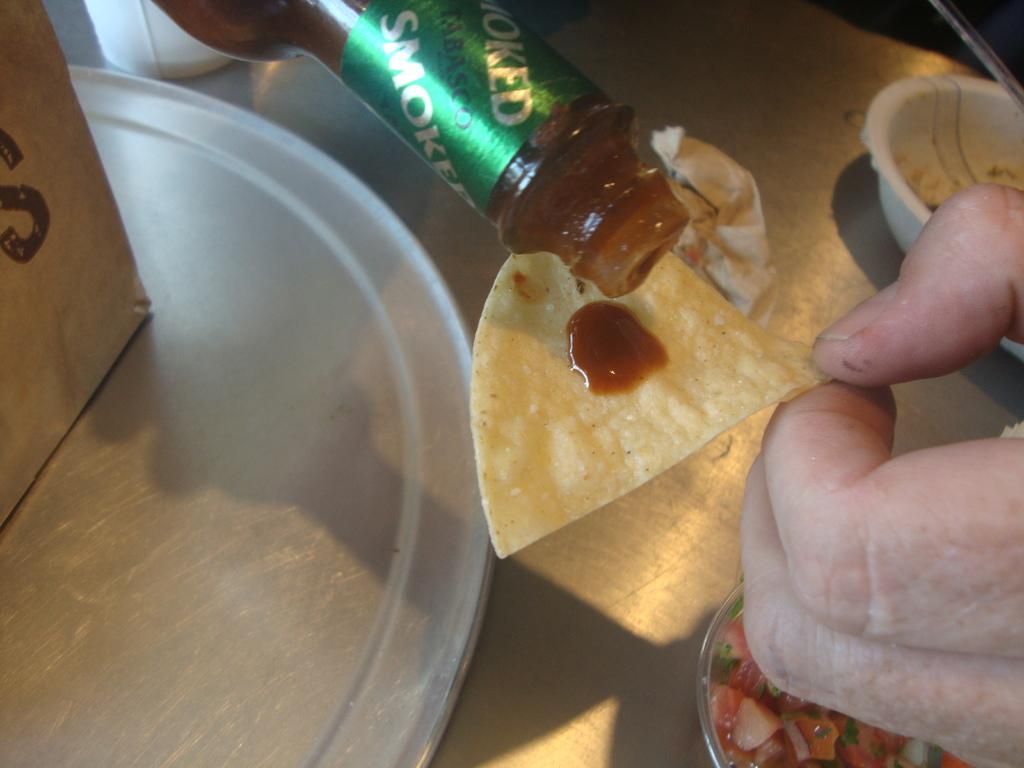<image>
Create a compact narrative representing the image presented. A bottle of Tabasco sauce is being poured on nacho chips 